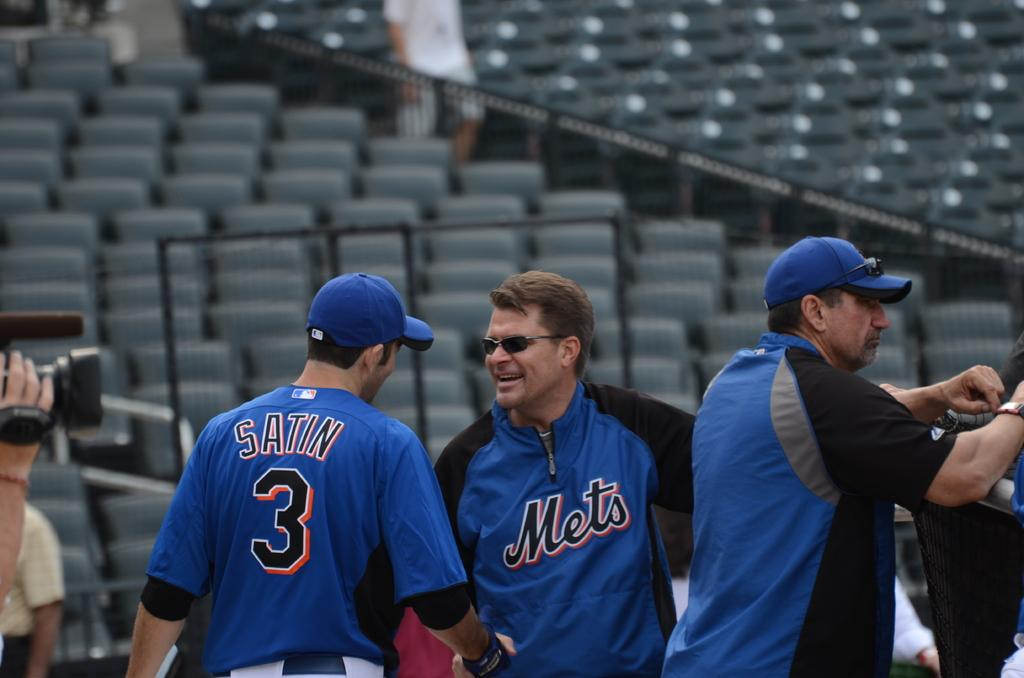Provide a one-sentence caption for the provided image. Men with Mets jerseys on speak to each other on a field. 